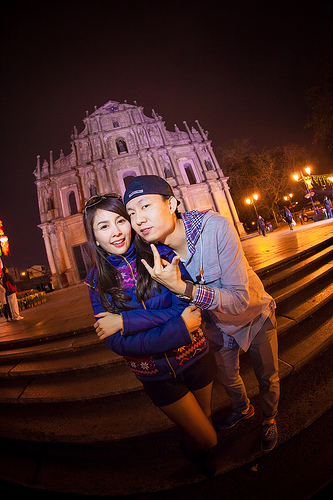<image>
Is there a building behind the man? Yes. From this viewpoint, the building is positioned behind the man, with the man partially or fully occluding the building. 